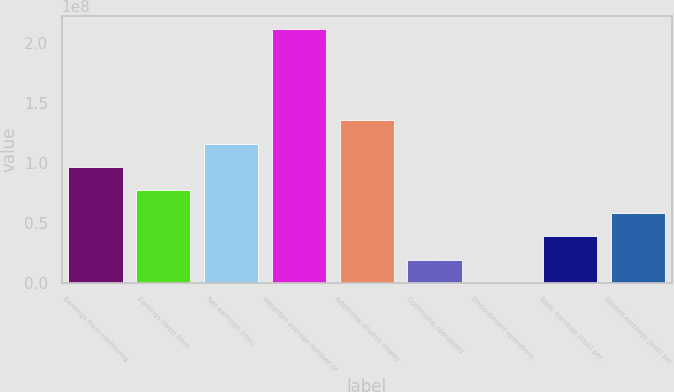<chart> <loc_0><loc_0><loc_500><loc_500><bar_chart><fcel>Earnings from continuing<fcel>Earnings (loss) from<fcel>Net earnings (loss)<fcel>Weighted average number of<fcel>Additional dilutive shares<fcel>Continuing operations<fcel>Discontinued operations<fcel>Basic earnings (loss) per<fcel>Diluted earnings (loss) per<nl><fcel>9.67873e+07<fcel>7.74299e+07<fcel>1.16145e+08<fcel>2.11995e+08<fcel>1.35502e+08<fcel>1.93575e+07<fcel>0.17<fcel>3.87149e+07<fcel>5.80724e+07<nl></chart> 